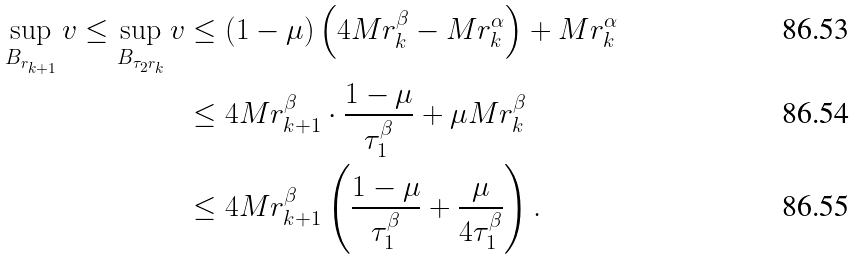Convert formula to latex. <formula><loc_0><loc_0><loc_500><loc_500>\sup _ { B _ { r _ { k + 1 } } } v \leq \sup _ { B _ { \tau _ { 2 } r _ { k } } } v & \leq ( 1 - \mu ) \left ( 4 M r _ { k } ^ { \beta } - M r _ { k } ^ { \alpha } \right ) + M r _ { k } ^ { \alpha } \\ & \leq 4 M r _ { k + 1 } ^ { \beta } \cdot \frac { 1 - \mu } { \tau _ { 1 } ^ { \beta } } + \mu M r _ { k } ^ { \beta } \\ & \leq 4 M r _ { k + 1 } ^ { \beta } \left ( \frac { 1 - \mu } { \tau _ { 1 } ^ { \beta } } + \frac { \mu } { 4 \tau _ { 1 } ^ { \beta } } \right ) .</formula> 